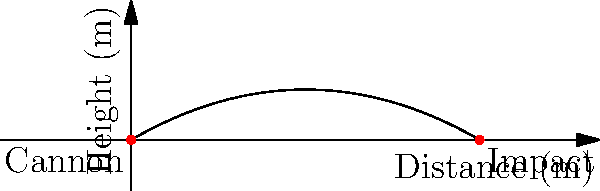A historical cannon from the 16th century launches a cannonball with an initial velocity of 50 m/s at an angle of 30° above the horizontal. Assuming air resistance is negligible, what is the maximum height reached by the cannonball during its flight? To find the maximum height of the projectile, we'll follow these steps:

1) The vertical component of the initial velocity is:
   $v_{0y} = v_0 \sin\theta = 50 \cdot \sin 30° = 25$ m/s

2) The time to reach maximum height is when the vertical velocity becomes zero:
   $v_y = v_{0y} - gt = 0$
   $t = \frac{v_{0y}}{g} = \frac{25}{9.8} \approx 2.55$ s

3) The maximum height is reached at half the total flight time. We can use the equation:
   $h = v_{0y}t - \frac{1}{2}gt^2$

4) Substituting the values:
   $h = 25 \cdot 2.55 - \frac{1}{2} \cdot 9.8 \cdot 2.55^2$
   $h = 63.75 - 31.875 = 31.875$ m

Therefore, the maximum height reached by the cannonball is approximately 31.88 meters.
Answer: 31.88 m 